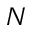<formula> <loc_0><loc_0><loc_500><loc_500>N</formula> 